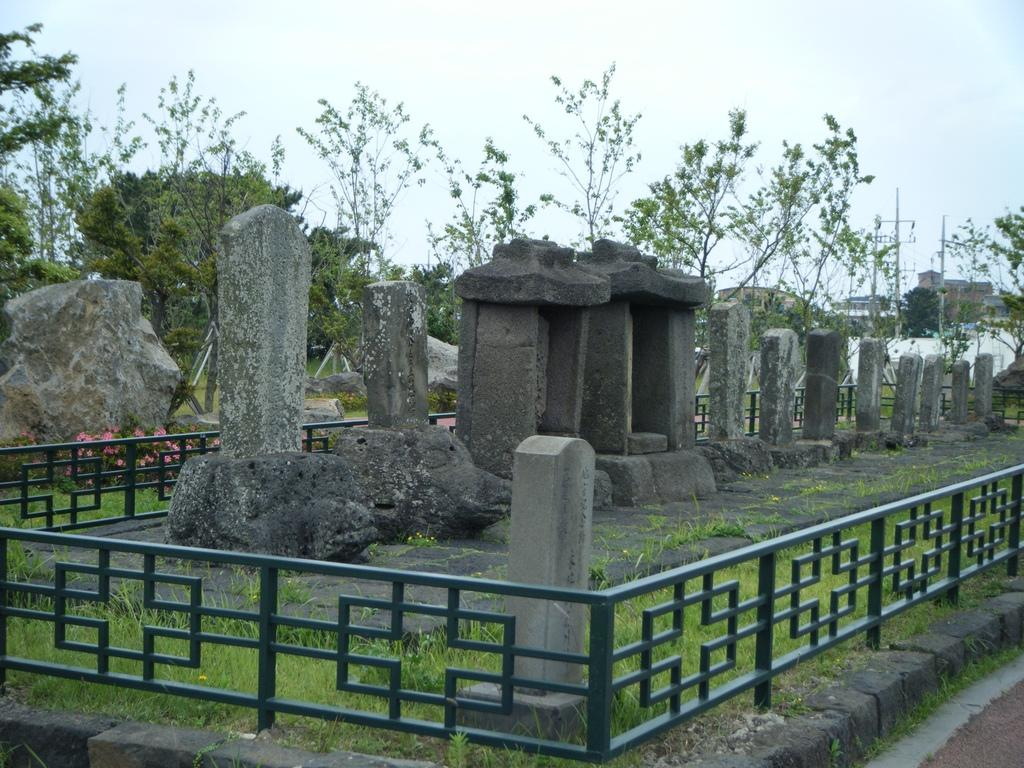What is placed around the stones in the image? There are grills around the stones in the image. What can be seen in the middle of the image? There are trees in the middle of the image. What is visible in the background of the image? There is a sky visible in the background of the image. What size ring is being worn by the tree in the image? There is no ring present on the tree in the image, as trees do not wear rings. 